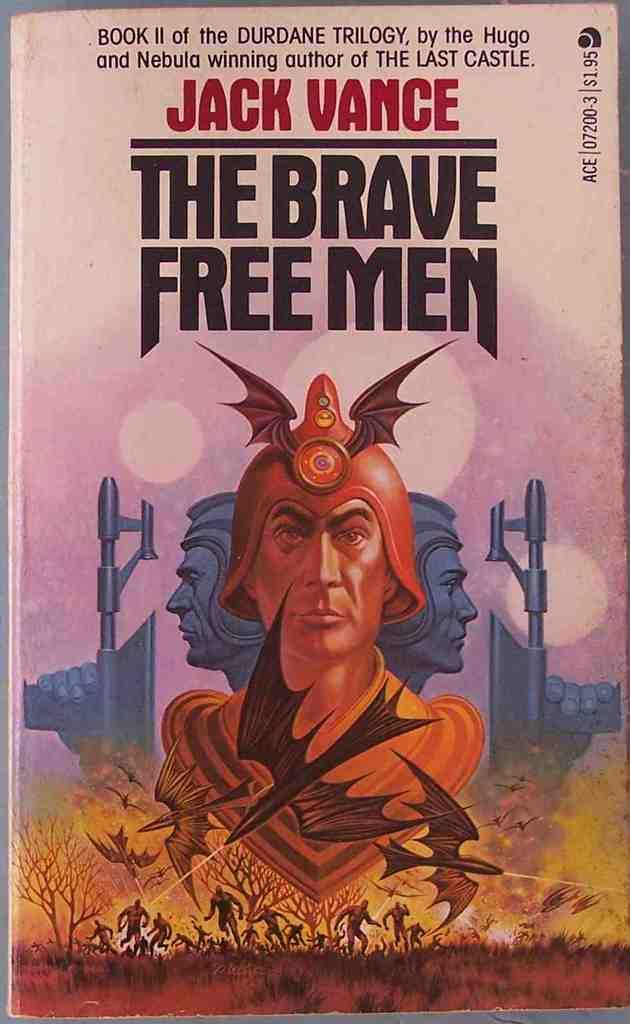What is the main object in the image? There is a book in the image. What type of content is present in the book? The book contains text. Are there any images in the book? Yes, the book contains an image of persons, an image of grass, and an image of trees. What color is the hydrant in the image? There is no hydrant present in the image. How many lines are visible in the image? The provided facts do not mention any lines in the image, so it is impossible to determine the number of lines. 